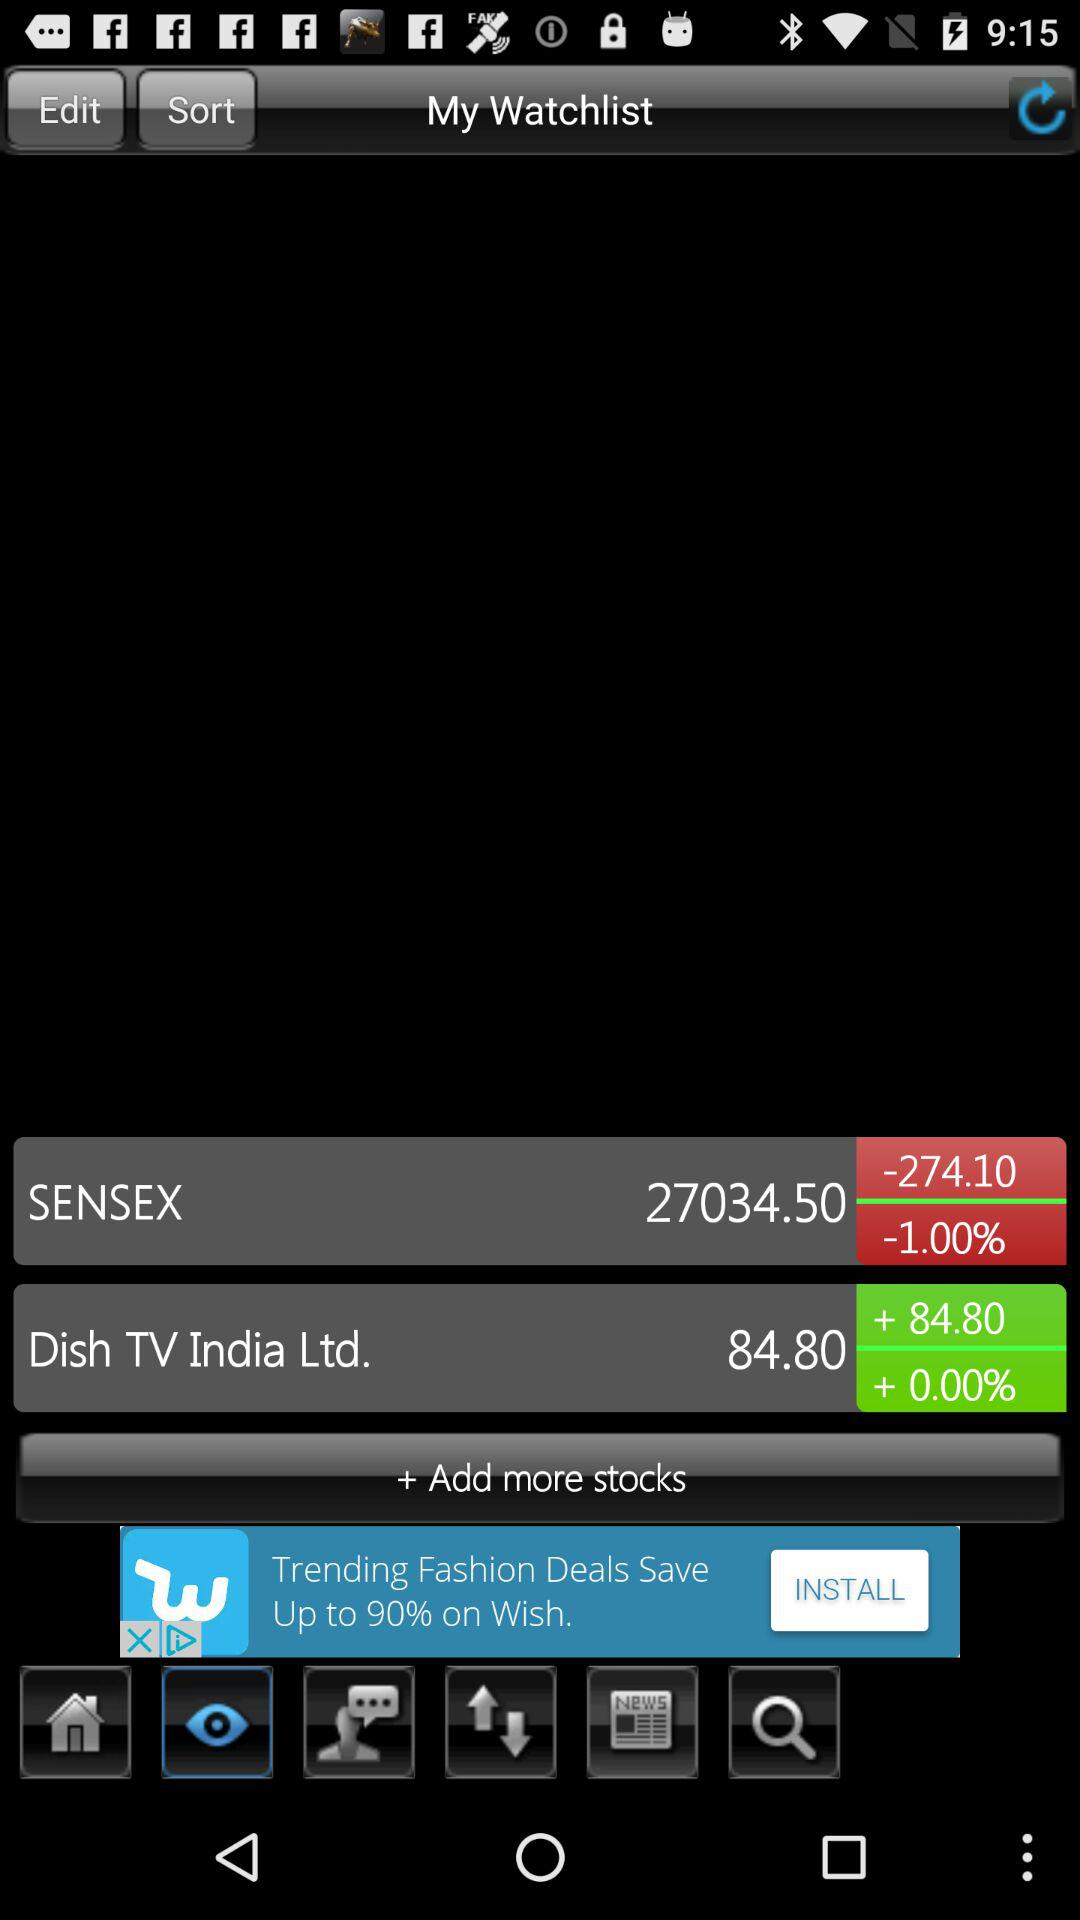Which tab is selected? The selected tab is "View". 